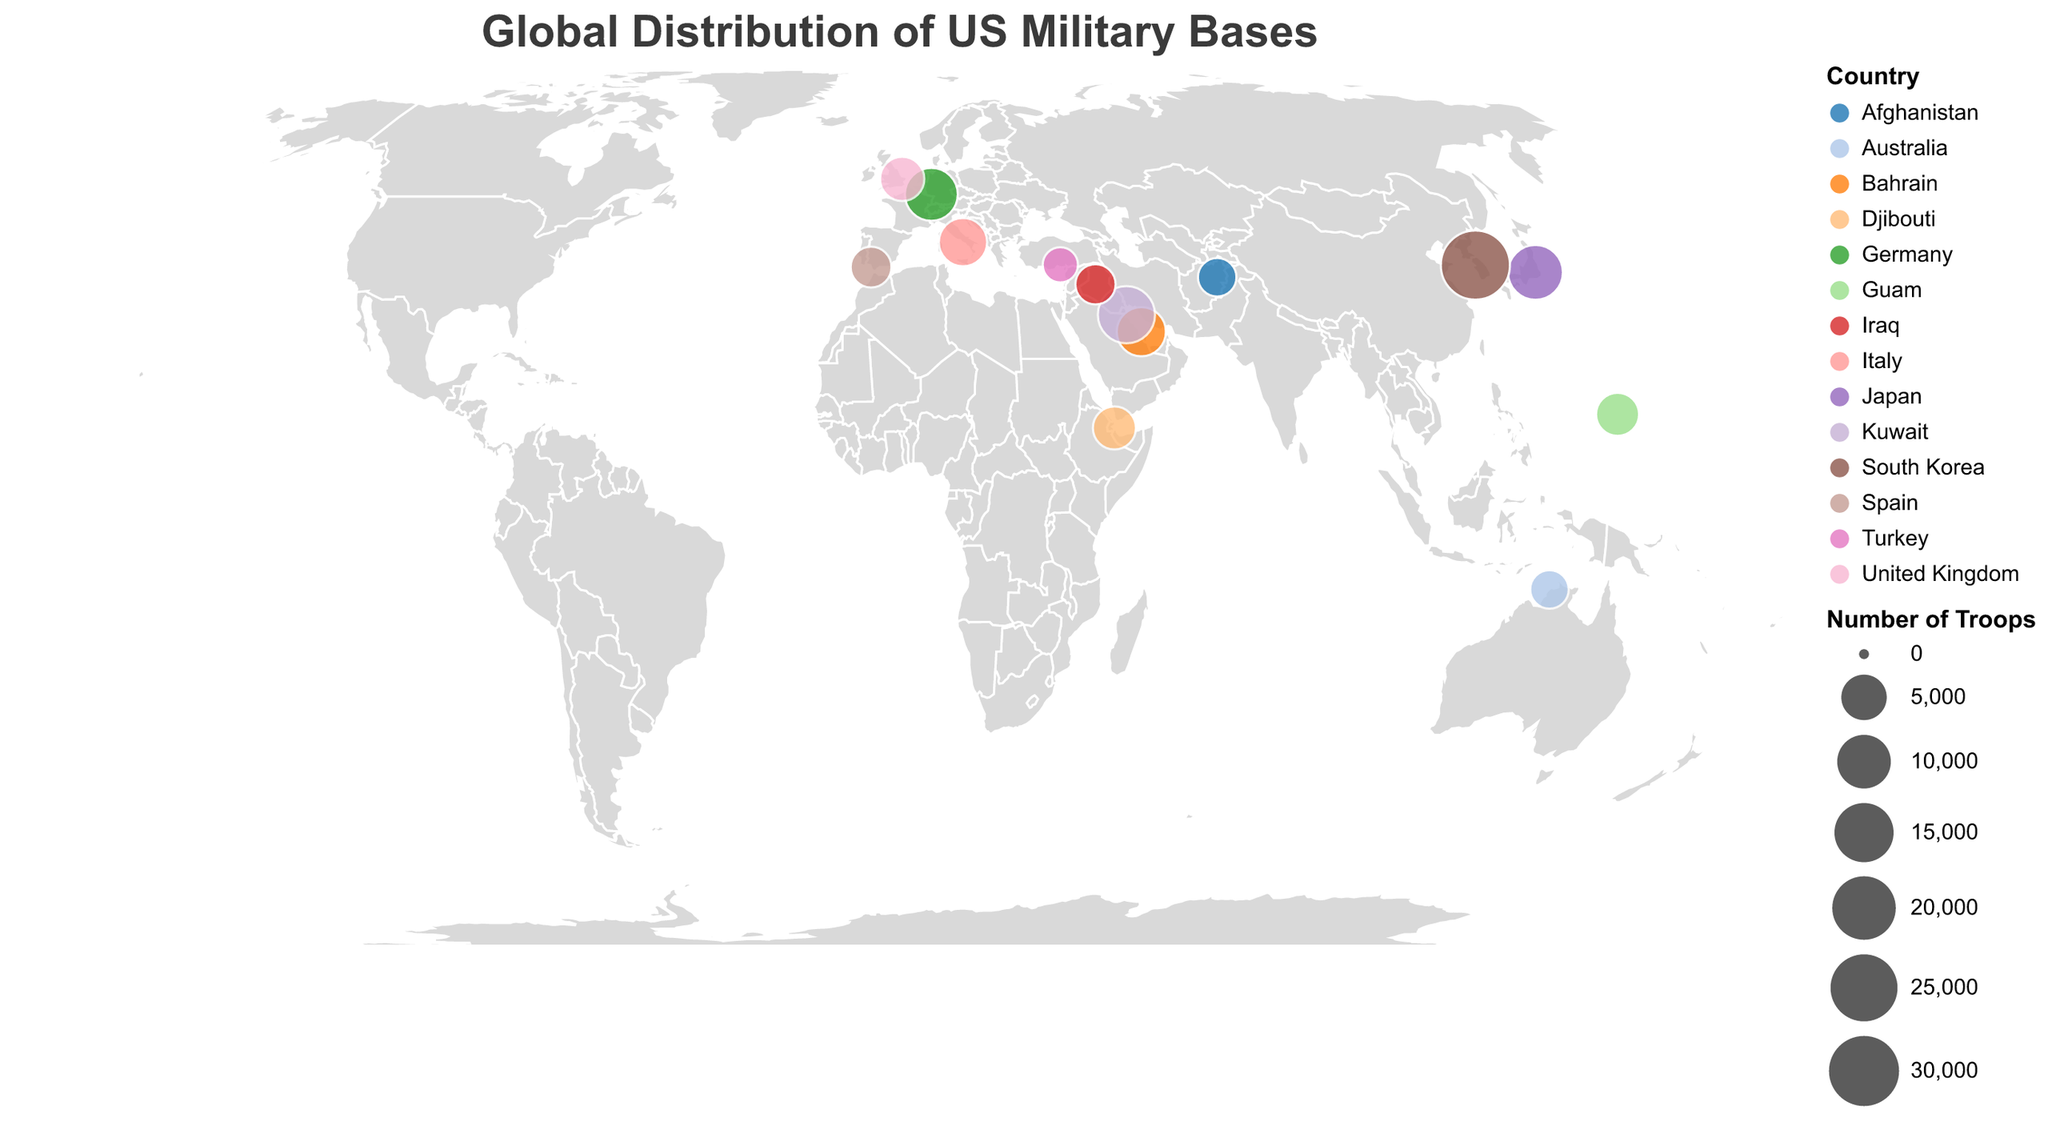What is the title of the figure? The title is written at the top of the figure.
Answer: Global Distribution of US Military Bases What color represents the countries? The color of the countries themselves is shown on the map background.
Answer: Light gray Which country has the highest number of US troops deployed? To determine this, you look for the largest circle on the map.
Answer: South Korea How many countries have more than 10,000 US troops deployed? Identify the circles with troop numbers greater than 10,000 by hovering over them.
Answer: Three (Japan, South Korea, Kuwait) What is the longitude of Naval Support Activity Bahrain? Hovering over the circle at the Bahrain location shows the geographic coordinates.
Answer: 50.6089 Which base in Europe has the highest number of troops? Locate the bases in Europe and compare their troop numbers.
Answer: Ramstein Air Base in Germany What is the smallest number of troops deployed to any military base on the plot? Identify the smallest circle and check the number of troops.
Answer: 1,700 (Incirlik Air Base in Turkey) How does the troop deployment in Japan compare to that in Germany? Look at the circle sizes and the number of troops for each country.
Answer: Japan has more troops (11,000) compared to Germany (9,500) What is the total number of US troops deployed in the bases listed in the figure? Sum up the number of troops from all the bases.
Answer: 108,900 How many bases are there with between 2,000 and 5,000 troops? Identify and count the circles where the troop numbers lie between 2,000 and 5,000.
Answer: Four (Bagram Airfield, Al Asad Airbase, Robertson Barracks, Camp Lemonnier) 